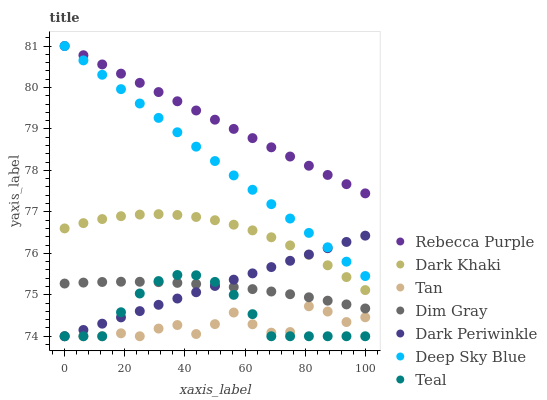Does Tan have the minimum area under the curve?
Answer yes or no. Yes. Does Rebecca Purple have the maximum area under the curve?
Answer yes or no. Yes. Does Teal have the minimum area under the curve?
Answer yes or no. No. Does Teal have the maximum area under the curve?
Answer yes or no. No. Is Rebecca Purple the smoothest?
Answer yes or no. Yes. Is Tan the roughest?
Answer yes or no. Yes. Is Teal the smoothest?
Answer yes or no. No. Is Teal the roughest?
Answer yes or no. No. Does Teal have the lowest value?
Answer yes or no. Yes. Does Dark Khaki have the lowest value?
Answer yes or no. No. Does Deep Sky Blue have the highest value?
Answer yes or no. Yes. Does Teal have the highest value?
Answer yes or no. No. Is Teal less than Deep Sky Blue?
Answer yes or no. Yes. Is Deep Sky Blue greater than Tan?
Answer yes or no. Yes. Does Dim Gray intersect Dark Periwinkle?
Answer yes or no. Yes. Is Dim Gray less than Dark Periwinkle?
Answer yes or no. No. Is Dim Gray greater than Dark Periwinkle?
Answer yes or no. No. Does Teal intersect Deep Sky Blue?
Answer yes or no. No. 